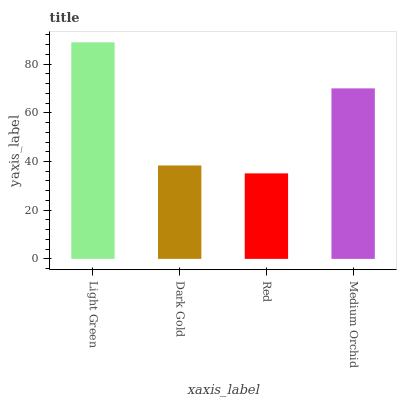Is Red the minimum?
Answer yes or no. Yes. Is Light Green the maximum?
Answer yes or no. Yes. Is Dark Gold the minimum?
Answer yes or no. No. Is Dark Gold the maximum?
Answer yes or no. No. Is Light Green greater than Dark Gold?
Answer yes or no. Yes. Is Dark Gold less than Light Green?
Answer yes or no. Yes. Is Dark Gold greater than Light Green?
Answer yes or no. No. Is Light Green less than Dark Gold?
Answer yes or no. No. Is Medium Orchid the high median?
Answer yes or no. Yes. Is Dark Gold the low median?
Answer yes or no. Yes. Is Light Green the high median?
Answer yes or no. No. Is Light Green the low median?
Answer yes or no. No. 